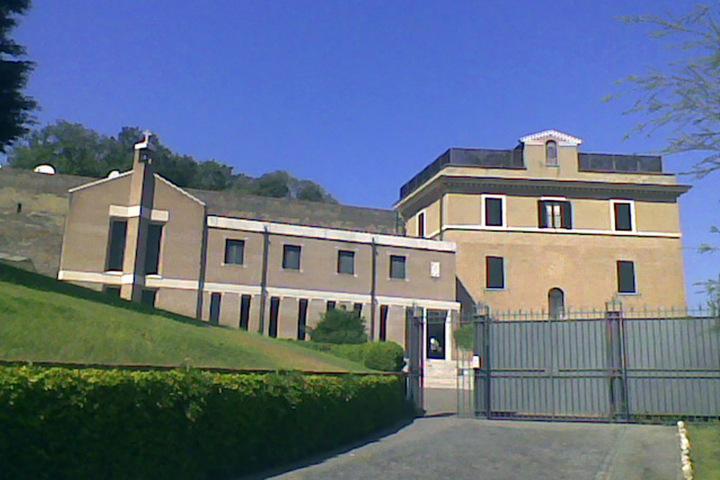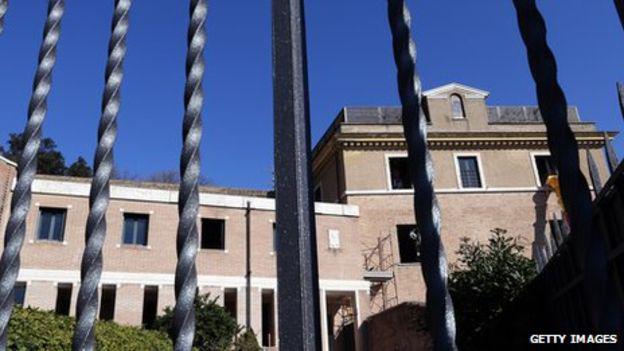The first image is the image on the left, the second image is the image on the right. Assess this claim about the two images: "There are stairs in the image on the left.". Correct or not? Answer yes or no. No. 